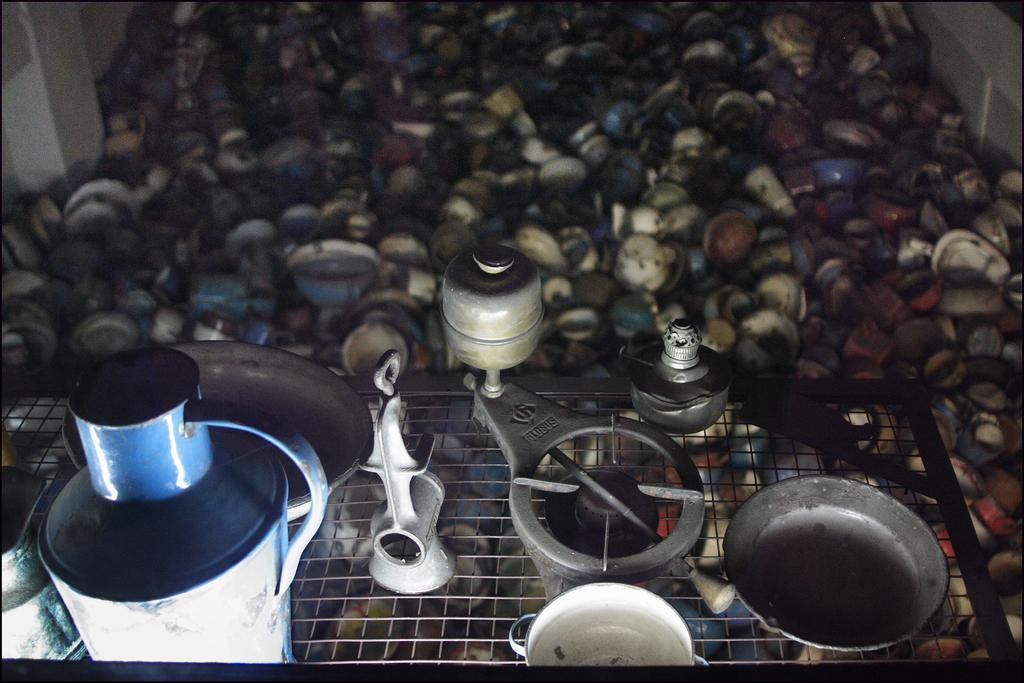What can be seen in the image? There are products and cups in the image. Can you describe the products in the image? Unfortunately, the provided facts do not give specific details about the products. How many cups are visible in the image? The number of cups is not specified in the provided facts. What type of root can be seen growing through the sidewalk in the image? There is no sidewalk or root present in the image. 